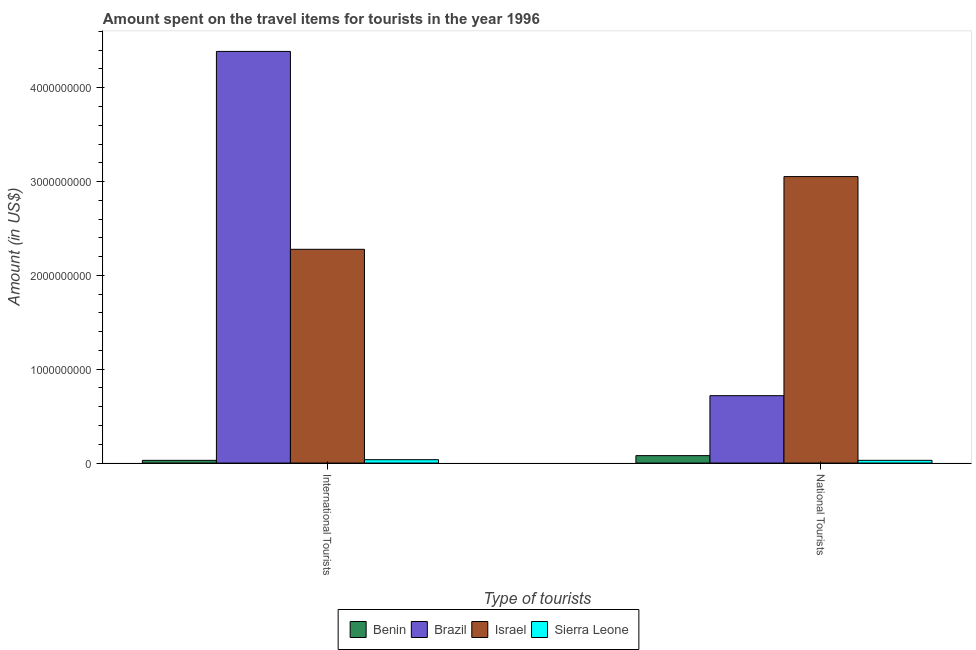How many different coloured bars are there?
Provide a succinct answer. 4. How many groups of bars are there?
Ensure brevity in your answer.  2. How many bars are there on the 1st tick from the left?
Offer a terse response. 4. How many bars are there on the 2nd tick from the right?
Provide a succinct answer. 4. What is the label of the 2nd group of bars from the left?
Keep it short and to the point. National Tourists. What is the amount spent on travel items of international tourists in Benin?
Give a very brief answer. 2.90e+07. Across all countries, what is the maximum amount spent on travel items of national tourists?
Your answer should be compact. 3.05e+09. Across all countries, what is the minimum amount spent on travel items of national tourists?
Offer a terse response. 2.90e+07. In which country was the amount spent on travel items of international tourists minimum?
Your answer should be compact. Benin. What is the total amount spent on travel items of national tourists in the graph?
Your response must be concise. 3.88e+09. What is the difference between the amount spent on travel items of international tourists in Sierra Leone and that in Israel?
Offer a very short reply. -2.24e+09. What is the difference between the amount spent on travel items of international tourists in Sierra Leone and the amount spent on travel items of national tourists in Benin?
Offer a very short reply. -4.30e+07. What is the average amount spent on travel items of national tourists per country?
Your response must be concise. 9.70e+08. What is the difference between the amount spent on travel items of national tourists and amount spent on travel items of international tourists in Sierra Leone?
Give a very brief answer. -7.00e+06. In how many countries, is the amount spent on travel items of national tourists greater than 800000000 US$?
Provide a succinct answer. 1. What is the ratio of the amount spent on travel items of national tourists in Benin to that in Israel?
Give a very brief answer. 0.03. Is the amount spent on travel items of national tourists in Israel less than that in Sierra Leone?
Offer a very short reply. No. In how many countries, is the amount spent on travel items of international tourists greater than the average amount spent on travel items of international tourists taken over all countries?
Give a very brief answer. 2. What does the 4th bar from the right in National Tourists represents?
Keep it short and to the point. Benin. How many bars are there?
Your answer should be very brief. 8. How many countries are there in the graph?
Your answer should be very brief. 4. What is the difference between two consecutive major ticks on the Y-axis?
Your response must be concise. 1.00e+09. Does the graph contain any zero values?
Your response must be concise. No. How many legend labels are there?
Make the answer very short. 4. How are the legend labels stacked?
Offer a very short reply. Horizontal. What is the title of the graph?
Provide a short and direct response. Amount spent on the travel items for tourists in the year 1996. Does "Liechtenstein" appear as one of the legend labels in the graph?
Provide a succinct answer. No. What is the label or title of the X-axis?
Offer a terse response. Type of tourists. What is the label or title of the Y-axis?
Keep it short and to the point. Amount (in US$). What is the Amount (in US$) of Benin in International Tourists?
Your response must be concise. 2.90e+07. What is the Amount (in US$) in Brazil in International Tourists?
Make the answer very short. 4.39e+09. What is the Amount (in US$) of Israel in International Tourists?
Your answer should be compact. 2.28e+09. What is the Amount (in US$) in Sierra Leone in International Tourists?
Your answer should be very brief. 3.60e+07. What is the Amount (in US$) of Benin in National Tourists?
Provide a succinct answer. 7.90e+07. What is the Amount (in US$) of Brazil in National Tourists?
Your response must be concise. 7.18e+08. What is the Amount (in US$) of Israel in National Tourists?
Provide a succinct answer. 3.05e+09. What is the Amount (in US$) in Sierra Leone in National Tourists?
Offer a very short reply. 2.90e+07. Across all Type of tourists, what is the maximum Amount (in US$) of Benin?
Offer a very short reply. 7.90e+07. Across all Type of tourists, what is the maximum Amount (in US$) of Brazil?
Offer a very short reply. 4.39e+09. Across all Type of tourists, what is the maximum Amount (in US$) in Israel?
Keep it short and to the point. 3.05e+09. Across all Type of tourists, what is the maximum Amount (in US$) in Sierra Leone?
Offer a very short reply. 3.60e+07. Across all Type of tourists, what is the minimum Amount (in US$) of Benin?
Your response must be concise. 2.90e+07. Across all Type of tourists, what is the minimum Amount (in US$) in Brazil?
Keep it short and to the point. 7.18e+08. Across all Type of tourists, what is the minimum Amount (in US$) in Israel?
Your answer should be very brief. 2.28e+09. Across all Type of tourists, what is the minimum Amount (in US$) of Sierra Leone?
Provide a short and direct response. 2.90e+07. What is the total Amount (in US$) in Benin in the graph?
Keep it short and to the point. 1.08e+08. What is the total Amount (in US$) in Brazil in the graph?
Your response must be concise. 5.10e+09. What is the total Amount (in US$) of Israel in the graph?
Offer a very short reply. 5.33e+09. What is the total Amount (in US$) in Sierra Leone in the graph?
Make the answer very short. 6.50e+07. What is the difference between the Amount (in US$) in Benin in International Tourists and that in National Tourists?
Provide a succinct answer. -5.00e+07. What is the difference between the Amount (in US$) in Brazil in International Tourists and that in National Tourists?
Provide a succinct answer. 3.67e+09. What is the difference between the Amount (in US$) in Israel in International Tourists and that in National Tourists?
Provide a succinct answer. -7.75e+08. What is the difference between the Amount (in US$) in Sierra Leone in International Tourists and that in National Tourists?
Provide a short and direct response. 7.00e+06. What is the difference between the Amount (in US$) of Benin in International Tourists and the Amount (in US$) of Brazil in National Tourists?
Your response must be concise. -6.89e+08. What is the difference between the Amount (in US$) of Benin in International Tourists and the Amount (in US$) of Israel in National Tourists?
Keep it short and to the point. -3.02e+09. What is the difference between the Amount (in US$) of Brazil in International Tourists and the Amount (in US$) of Israel in National Tourists?
Ensure brevity in your answer.  1.33e+09. What is the difference between the Amount (in US$) of Brazil in International Tourists and the Amount (in US$) of Sierra Leone in National Tourists?
Provide a short and direct response. 4.36e+09. What is the difference between the Amount (in US$) of Israel in International Tourists and the Amount (in US$) of Sierra Leone in National Tourists?
Provide a succinct answer. 2.25e+09. What is the average Amount (in US$) of Benin per Type of tourists?
Your response must be concise. 5.40e+07. What is the average Amount (in US$) in Brazil per Type of tourists?
Provide a succinct answer. 2.55e+09. What is the average Amount (in US$) of Israel per Type of tourists?
Ensure brevity in your answer.  2.67e+09. What is the average Amount (in US$) in Sierra Leone per Type of tourists?
Offer a very short reply. 3.25e+07. What is the difference between the Amount (in US$) of Benin and Amount (in US$) of Brazil in International Tourists?
Offer a terse response. -4.36e+09. What is the difference between the Amount (in US$) of Benin and Amount (in US$) of Israel in International Tourists?
Your answer should be very brief. -2.25e+09. What is the difference between the Amount (in US$) in Benin and Amount (in US$) in Sierra Leone in International Tourists?
Make the answer very short. -7.00e+06. What is the difference between the Amount (in US$) in Brazil and Amount (in US$) in Israel in International Tourists?
Keep it short and to the point. 2.11e+09. What is the difference between the Amount (in US$) of Brazil and Amount (in US$) of Sierra Leone in International Tourists?
Make the answer very short. 4.35e+09. What is the difference between the Amount (in US$) of Israel and Amount (in US$) of Sierra Leone in International Tourists?
Your answer should be compact. 2.24e+09. What is the difference between the Amount (in US$) in Benin and Amount (in US$) in Brazil in National Tourists?
Give a very brief answer. -6.39e+08. What is the difference between the Amount (in US$) of Benin and Amount (in US$) of Israel in National Tourists?
Your answer should be compact. -2.97e+09. What is the difference between the Amount (in US$) of Benin and Amount (in US$) of Sierra Leone in National Tourists?
Your response must be concise. 5.00e+07. What is the difference between the Amount (in US$) of Brazil and Amount (in US$) of Israel in National Tourists?
Ensure brevity in your answer.  -2.34e+09. What is the difference between the Amount (in US$) of Brazil and Amount (in US$) of Sierra Leone in National Tourists?
Keep it short and to the point. 6.89e+08. What is the difference between the Amount (in US$) of Israel and Amount (in US$) of Sierra Leone in National Tourists?
Offer a terse response. 3.02e+09. What is the ratio of the Amount (in US$) of Benin in International Tourists to that in National Tourists?
Your response must be concise. 0.37. What is the ratio of the Amount (in US$) of Brazil in International Tourists to that in National Tourists?
Ensure brevity in your answer.  6.11. What is the ratio of the Amount (in US$) of Israel in International Tourists to that in National Tourists?
Ensure brevity in your answer.  0.75. What is the ratio of the Amount (in US$) in Sierra Leone in International Tourists to that in National Tourists?
Your answer should be compact. 1.24. What is the difference between the highest and the second highest Amount (in US$) in Brazil?
Your response must be concise. 3.67e+09. What is the difference between the highest and the second highest Amount (in US$) in Israel?
Give a very brief answer. 7.75e+08. What is the difference between the highest and the lowest Amount (in US$) in Brazil?
Provide a succinct answer. 3.67e+09. What is the difference between the highest and the lowest Amount (in US$) of Israel?
Ensure brevity in your answer.  7.75e+08. What is the difference between the highest and the lowest Amount (in US$) in Sierra Leone?
Provide a short and direct response. 7.00e+06. 